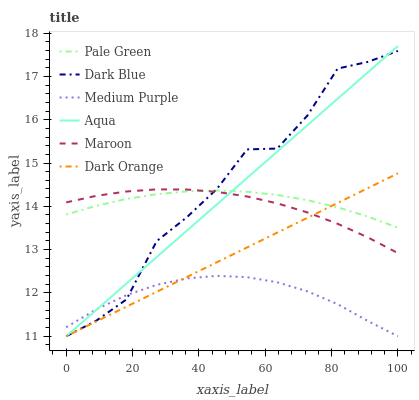Does Medium Purple have the minimum area under the curve?
Answer yes or no. Yes. Does Dark Blue have the maximum area under the curve?
Answer yes or no. Yes. Does Aqua have the minimum area under the curve?
Answer yes or no. No. Does Aqua have the maximum area under the curve?
Answer yes or no. No. Is Dark Orange the smoothest?
Answer yes or no. Yes. Is Dark Blue the roughest?
Answer yes or no. Yes. Is Aqua the smoothest?
Answer yes or no. No. Is Aqua the roughest?
Answer yes or no. No. Does Dark Orange have the lowest value?
Answer yes or no. Yes. Does Maroon have the lowest value?
Answer yes or no. No. Does Aqua have the highest value?
Answer yes or no. Yes. Does Maroon have the highest value?
Answer yes or no. No. Is Medium Purple less than Pale Green?
Answer yes or no. Yes. Is Pale Green greater than Medium Purple?
Answer yes or no. Yes. Does Maroon intersect Dark Orange?
Answer yes or no. Yes. Is Maroon less than Dark Orange?
Answer yes or no. No. Is Maroon greater than Dark Orange?
Answer yes or no. No. Does Medium Purple intersect Pale Green?
Answer yes or no. No. 